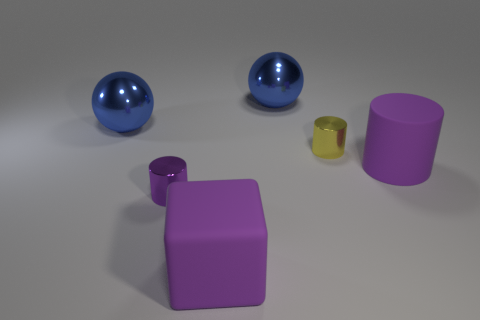Subtract all big purple cylinders. How many cylinders are left? 2 Subtract all blue balls. How many purple cylinders are left? 2 Add 1 brown rubber cylinders. How many objects exist? 7 Subtract 1 cylinders. How many cylinders are left? 2 Subtract 0 cyan spheres. How many objects are left? 6 Subtract all balls. How many objects are left? 4 Subtract all red cylinders. Subtract all brown blocks. How many cylinders are left? 3 Subtract all big blue shiny balls. Subtract all yellow cylinders. How many objects are left? 3 Add 4 cubes. How many cubes are left? 5 Add 5 big blue metallic balls. How many big blue metallic balls exist? 7 